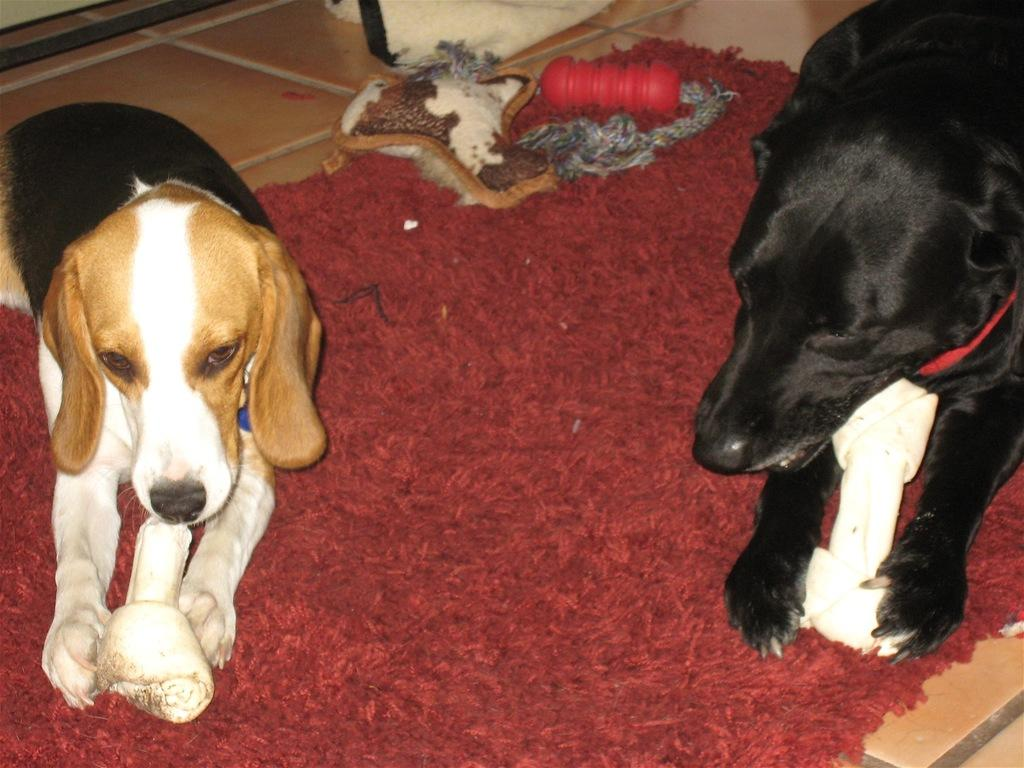How many dogs are in the image? There are two dogs in the image. What are the dogs holding in their mouths? The dogs have bones in their mouths. Where are the dogs sitting? The dogs are sitting on a mat. What else can be seen on the mat? There are objects on the mat. Where is the mat located? The mat is on the floor. What type of leaf can be seen falling from the sky in the image? There is no leaf falling from the sky in the image; it only features two dogs with bones in their mouths, sitting on a mat on the floor. 